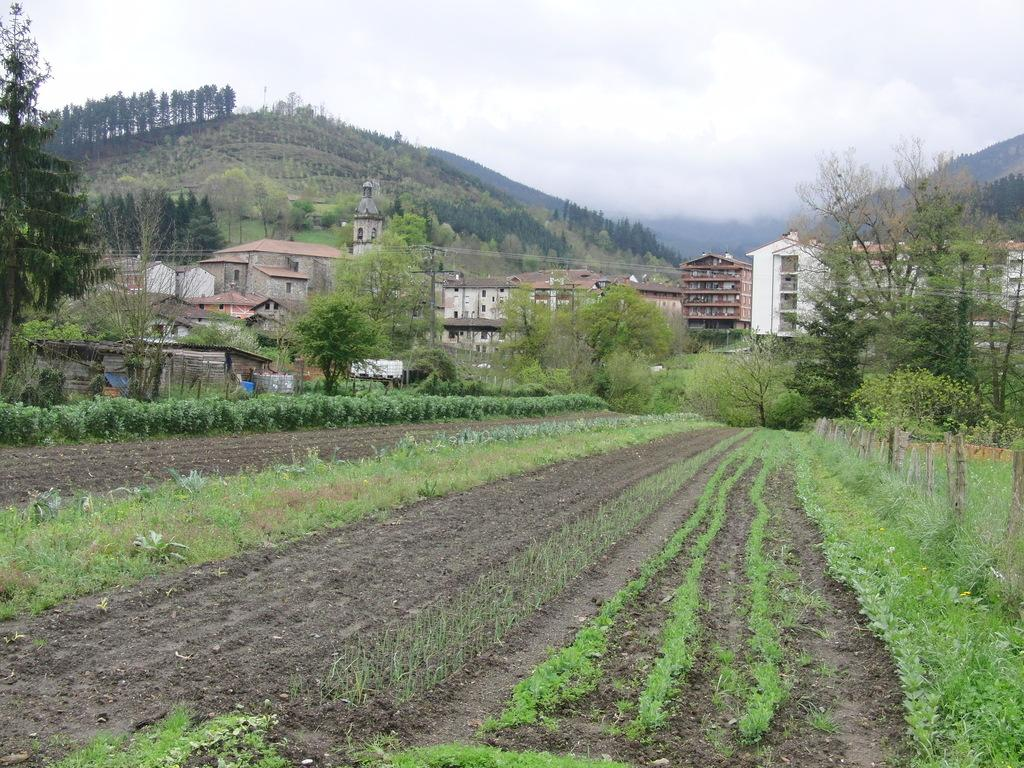What type of landscape is depicted in the image? The image features fields. What can be seen in the background of the image? In the background, there are hills, trees, buildings, and a tower. What type of honey is being produced by the trees in the image? There is no honey production mentioned or depicted in the image; it features fields, hills, trees, buildings, and a tower. 